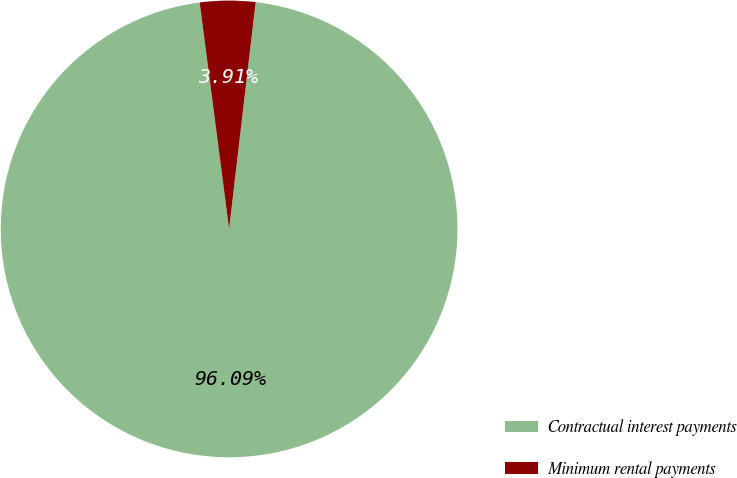<chart> <loc_0><loc_0><loc_500><loc_500><pie_chart><fcel>Contractual interest payments<fcel>Minimum rental payments<nl><fcel>96.09%<fcel>3.91%<nl></chart> 